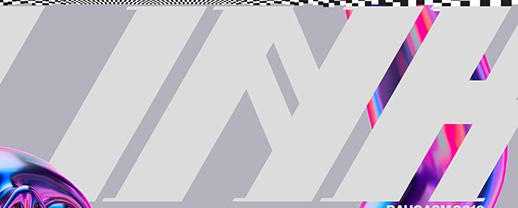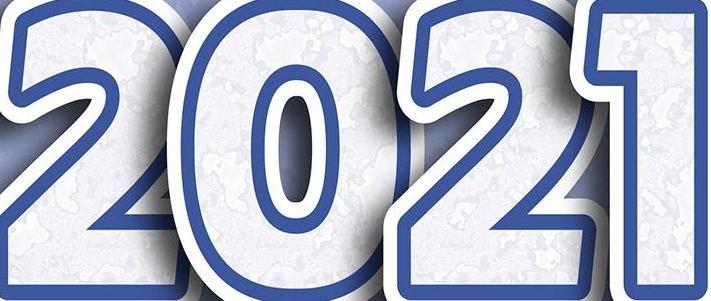What words can you see in these images in sequence, separated by a semicolon? INH; 2021 